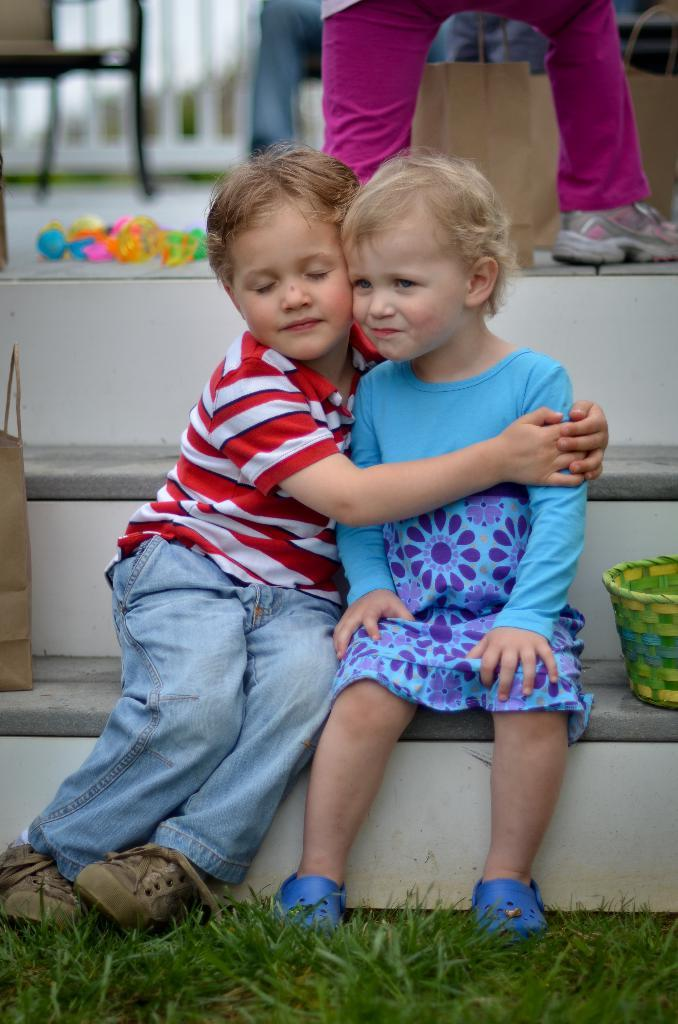How many children are sitting in the image? There are two children sitting in the image. What type of surface are the children sitting on? There is grass visible in the image, which suggests they are sitting on grass. What object is green in the image? There is a green basket in the image. What items might be used for carrying things in the image? There are carry bags in the image. Can you describe another person in the image besides the children? There is at least one other person in the image. Are there any fairies visible in the image? There are no fairies present in the image. What type of boundary can be seen in the image? There is no boundary visible in the image. 